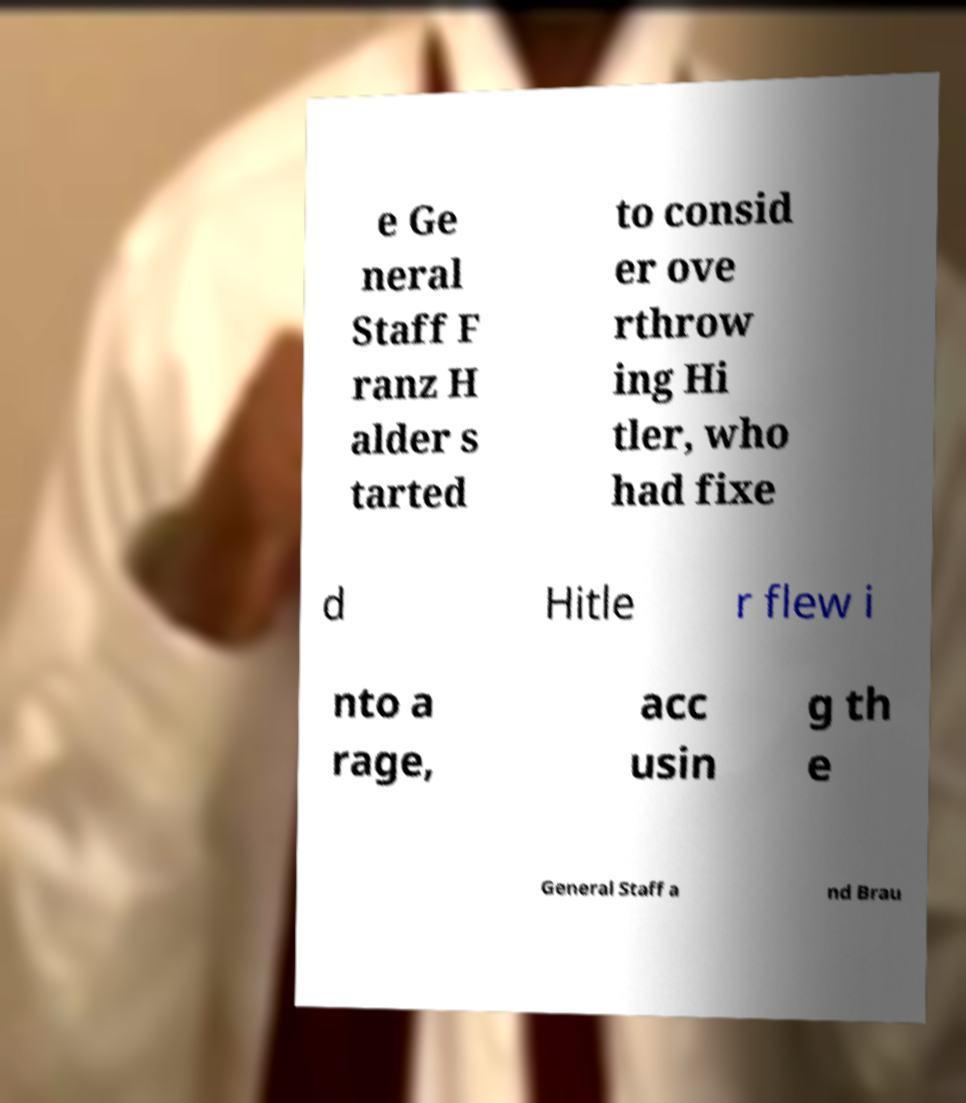Please read and relay the text visible in this image. What does it say? e Ge neral Staff F ranz H alder s tarted to consid er ove rthrow ing Hi tler, who had fixe d Hitle r flew i nto a rage, acc usin g th e General Staff a nd Brau 